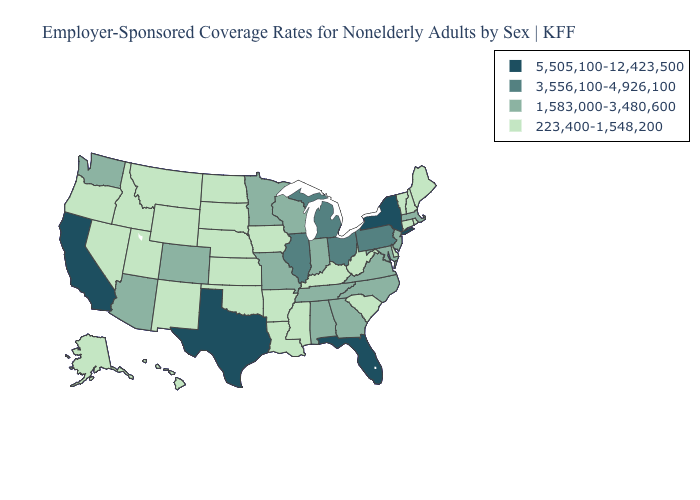Name the states that have a value in the range 3,556,100-4,926,100?
Quick response, please. Illinois, Michigan, Ohio, Pennsylvania. What is the value of New Jersey?
Quick response, please. 1,583,000-3,480,600. What is the highest value in the South ?
Give a very brief answer. 5,505,100-12,423,500. Name the states that have a value in the range 5,505,100-12,423,500?
Concise answer only. California, Florida, New York, Texas. Name the states that have a value in the range 223,400-1,548,200?
Short answer required. Alaska, Arkansas, Connecticut, Delaware, Hawaii, Idaho, Iowa, Kansas, Kentucky, Louisiana, Maine, Mississippi, Montana, Nebraska, Nevada, New Hampshire, New Mexico, North Dakota, Oklahoma, Oregon, Rhode Island, South Carolina, South Dakota, Utah, Vermont, West Virginia, Wyoming. Which states have the highest value in the USA?
Short answer required. California, Florida, New York, Texas. What is the value of Alabama?
Quick response, please. 1,583,000-3,480,600. What is the highest value in the MidWest ?
Concise answer only. 3,556,100-4,926,100. What is the highest value in the South ?
Answer briefly. 5,505,100-12,423,500. Which states have the lowest value in the South?
Concise answer only. Arkansas, Delaware, Kentucky, Louisiana, Mississippi, Oklahoma, South Carolina, West Virginia. What is the value of Colorado?
Write a very short answer. 1,583,000-3,480,600. What is the highest value in the USA?
Short answer required. 5,505,100-12,423,500. Does the first symbol in the legend represent the smallest category?
Keep it brief. No. Name the states that have a value in the range 1,583,000-3,480,600?
Write a very short answer. Alabama, Arizona, Colorado, Georgia, Indiana, Maryland, Massachusetts, Minnesota, Missouri, New Jersey, North Carolina, Tennessee, Virginia, Washington, Wisconsin. What is the lowest value in the USA?
Keep it brief. 223,400-1,548,200. 